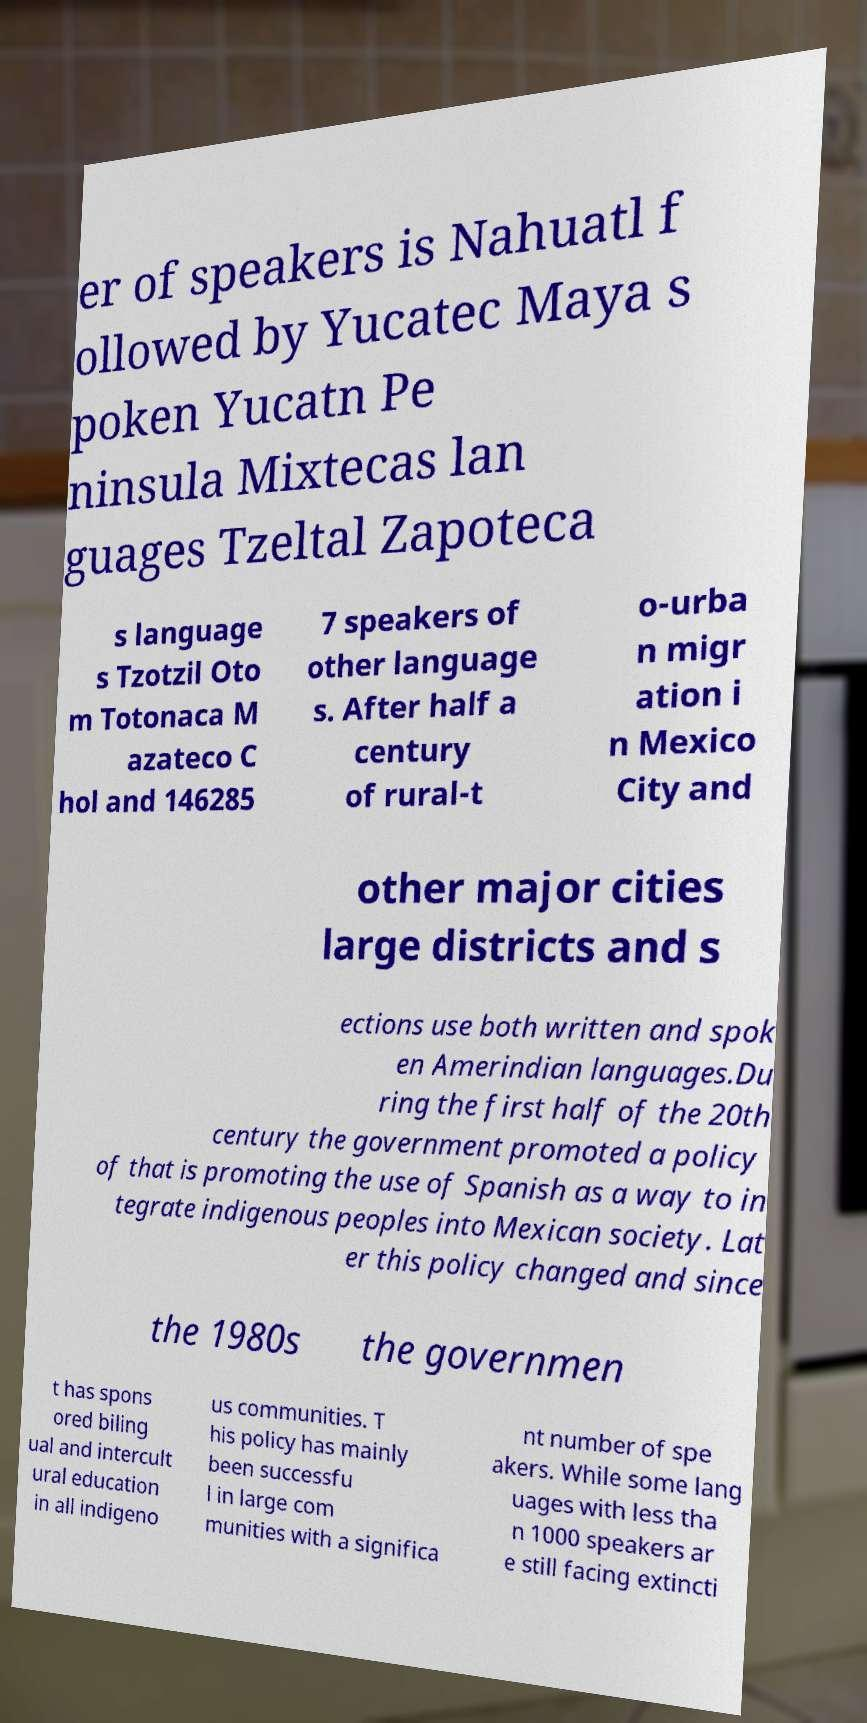Could you assist in decoding the text presented in this image and type it out clearly? er of speakers is Nahuatl f ollowed by Yucatec Maya s poken Yucatn Pe ninsula Mixtecas lan guages Tzeltal Zapoteca s language s Tzotzil Oto m Totonaca M azateco C hol and 146285 7 speakers of other language s. After half a century of rural-t o-urba n migr ation i n Mexico City and other major cities large districts and s ections use both written and spok en Amerindian languages.Du ring the first half of the 20th century the government promoted a policy of that is promoting the use of Spanish as a way to in tegrate indigenous peoples into Mexican society. Lat er this policy changed and since the 1980s the governmen t has spons ored biling ual and intercult ural education in all indigeno us communities. T his policy has mainly been successfu l in large com munities with a significa nt number of spe akers. While some lang uages with less tha n 1000 speakers ar e still facing extincti 